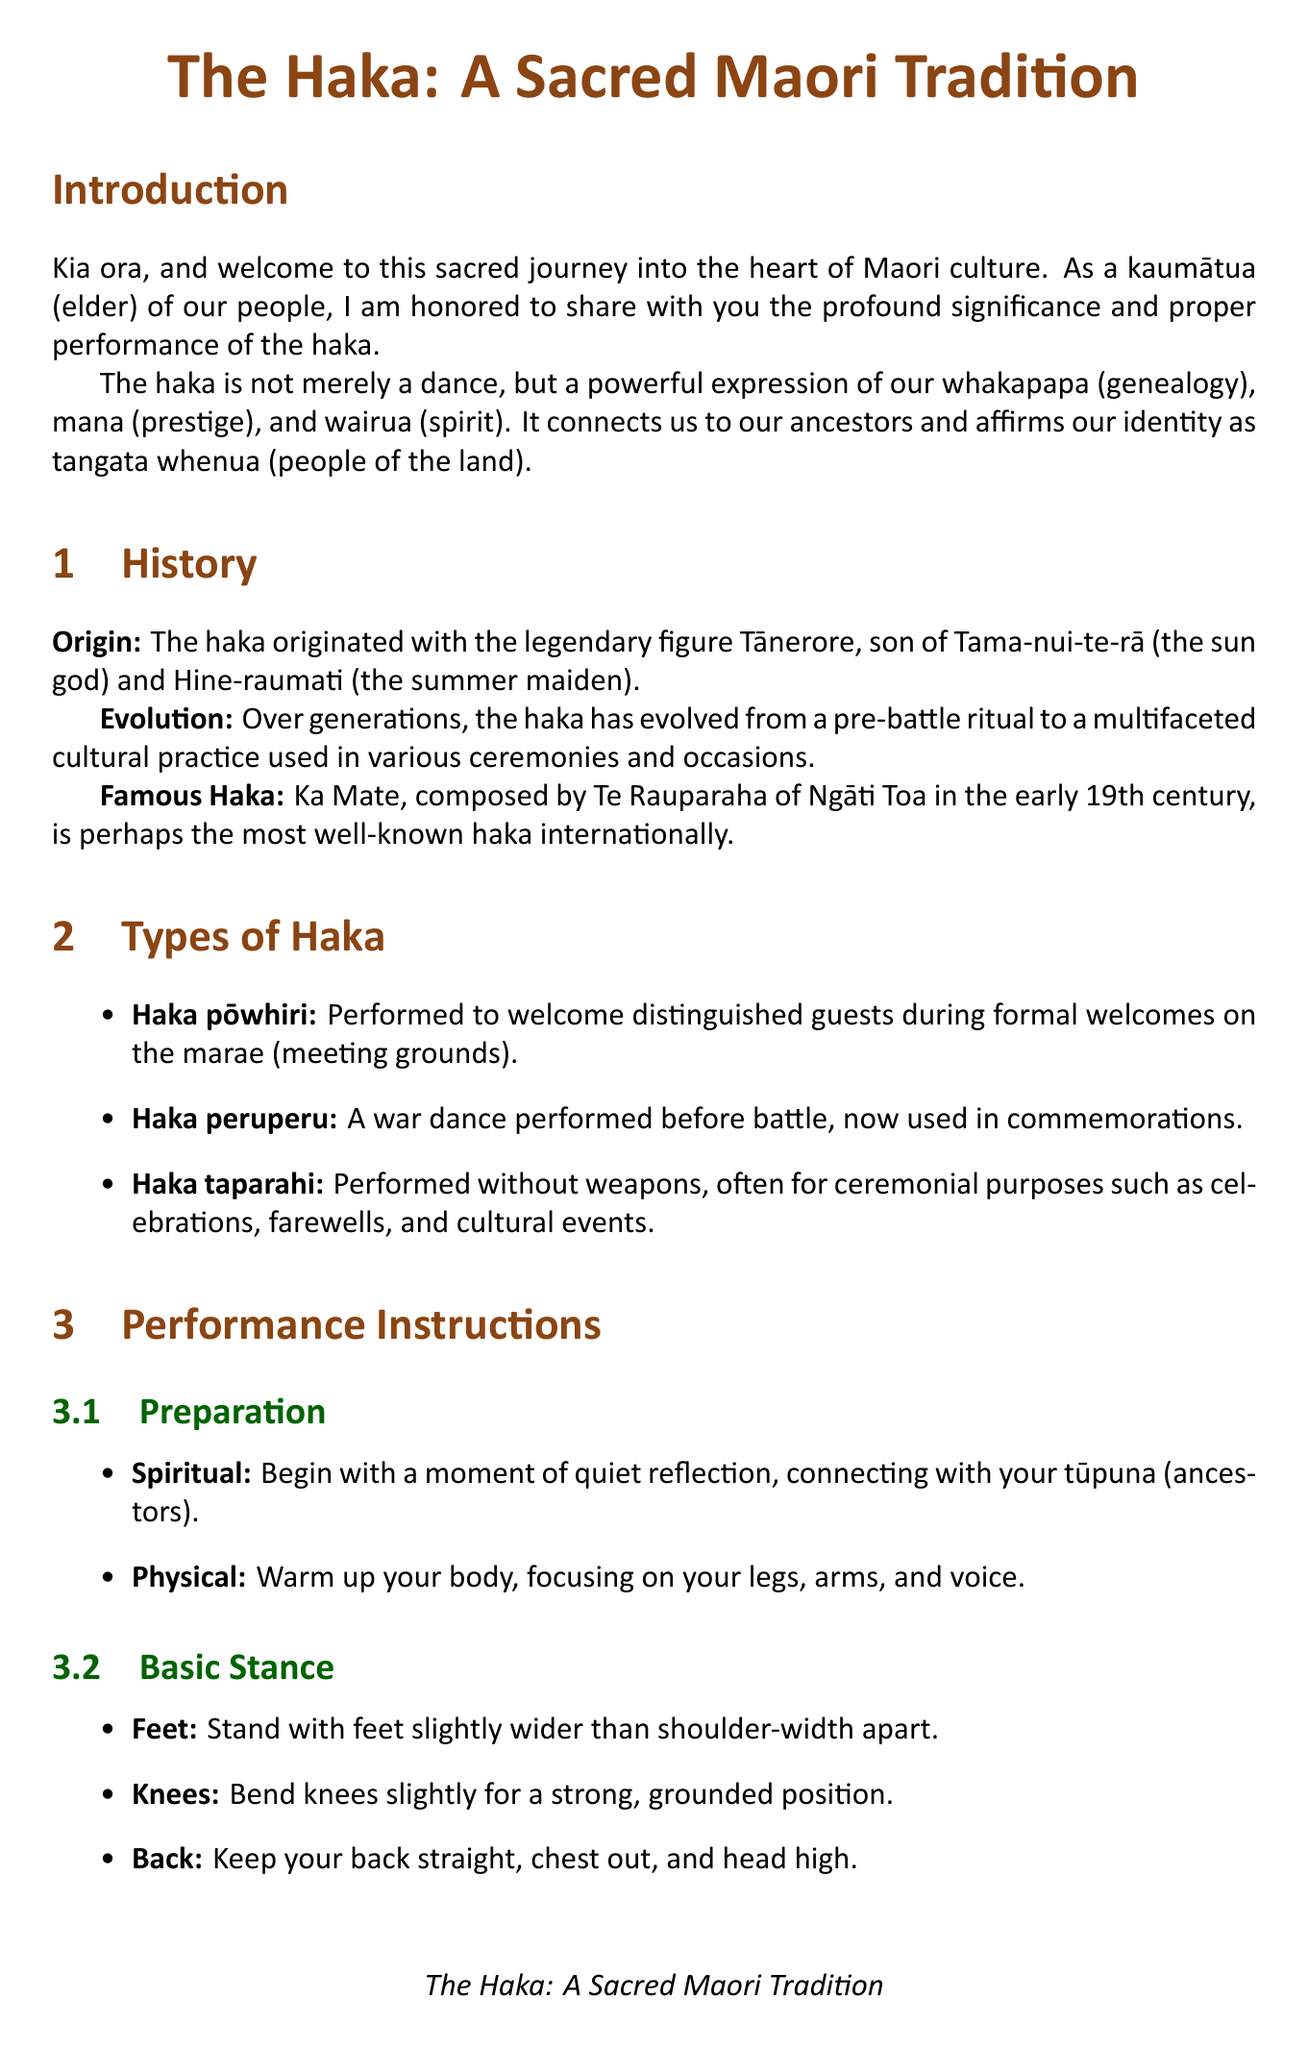What is the title of the manual? The title is stated at the beginning of the document.
Answer: The Haka: A Sacred Maori Tradition Who composed the famous haka Ka Mate? This information is provided in the history section, highlighting a notable figure.
Answer: Te Rauparaha What is the description of Haka pōwhiri? The document includes descriptions for different types of haka, including Haka pōwhiri.
Answer: Performed to welcome distinguished guests How many types of haka are mentioned in the document? The document lists different types of haka, and a count can be derived from that information.
Answer: Three What do you need to seek before performing the haka? This requirement is found in the cultural protocol section on respect and permissions.
Answer: Guidance What should the vocalization maintain during the performance? The performance instructions indicate a specific aspect that needs to be upheld during vocalization.
Answer: The beat What gesture is associated with the facial expression "whētero"? This expression is part of the facial expression instructions provided in the performance section.
Answer: Protrude the tongue What does "kia kaha" mean in the context of the conclusion? The conclusion provides a farewell message that contains phrases with a cultural context.
Answer: Be strong 